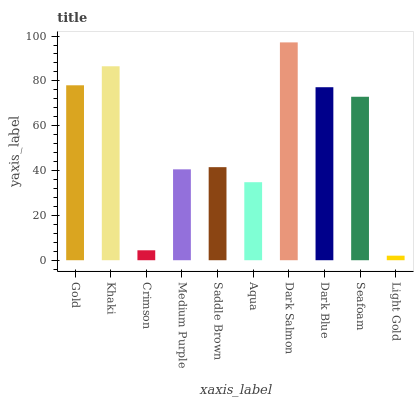Is Light Gold the minimum?
Answer yes or no. Yes. Is Dark Salmon the maximum?
Answer yes or no. Yes. Is Khaki the minimum?
Answer yes or no. No. Is Khaki the maximum?
Answer yes or no. No. Is Khaki greater than Gold?
Answer yes or no. Yes. Is Gold less than Khaki?
Answer yes or no. Yes. Is Gold greater than Khaki?
Answer yes or no. No. Is Khaki less than Gold?
Answer yes or no. No. Is Seafoam the high median?
Answer yes or no. Yes. Is Saddle Brown the low median?
Answer yes or no. Yes. Is Light Gold the high median?
Answer yes or no. No. Is Dark Blue the low median?
Answer yes or no. No. 